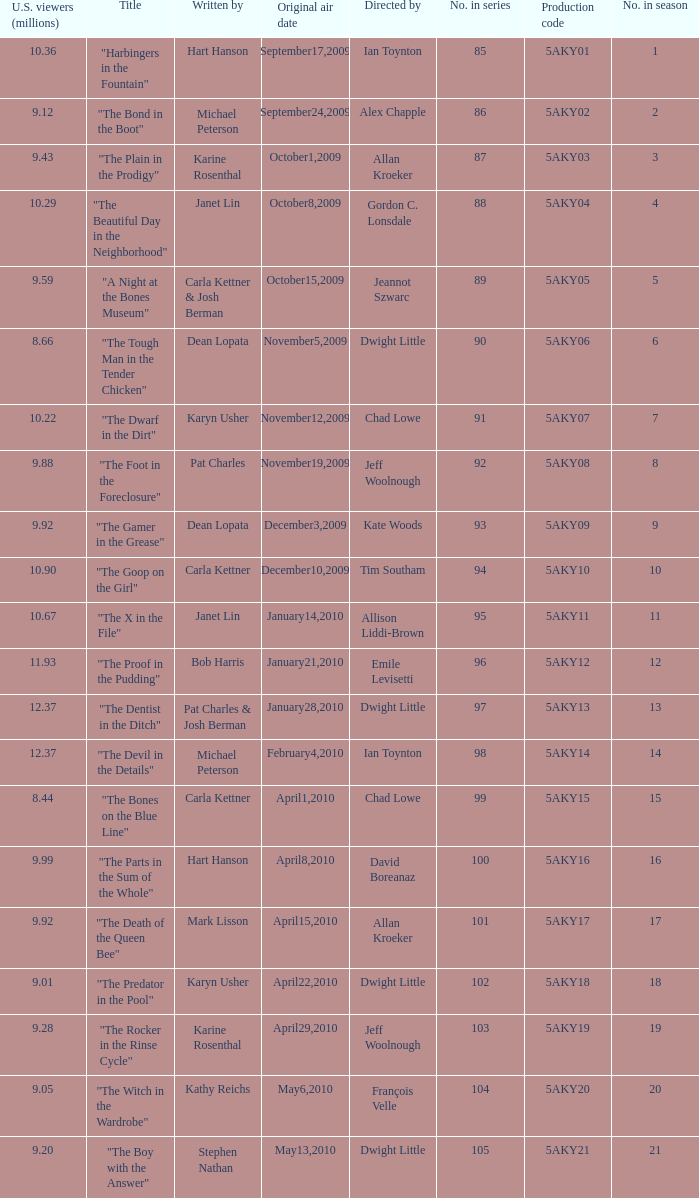How many were the US viewers (in millions) of the episode that was written by Gordon C. Lonsdale? 10.29. 